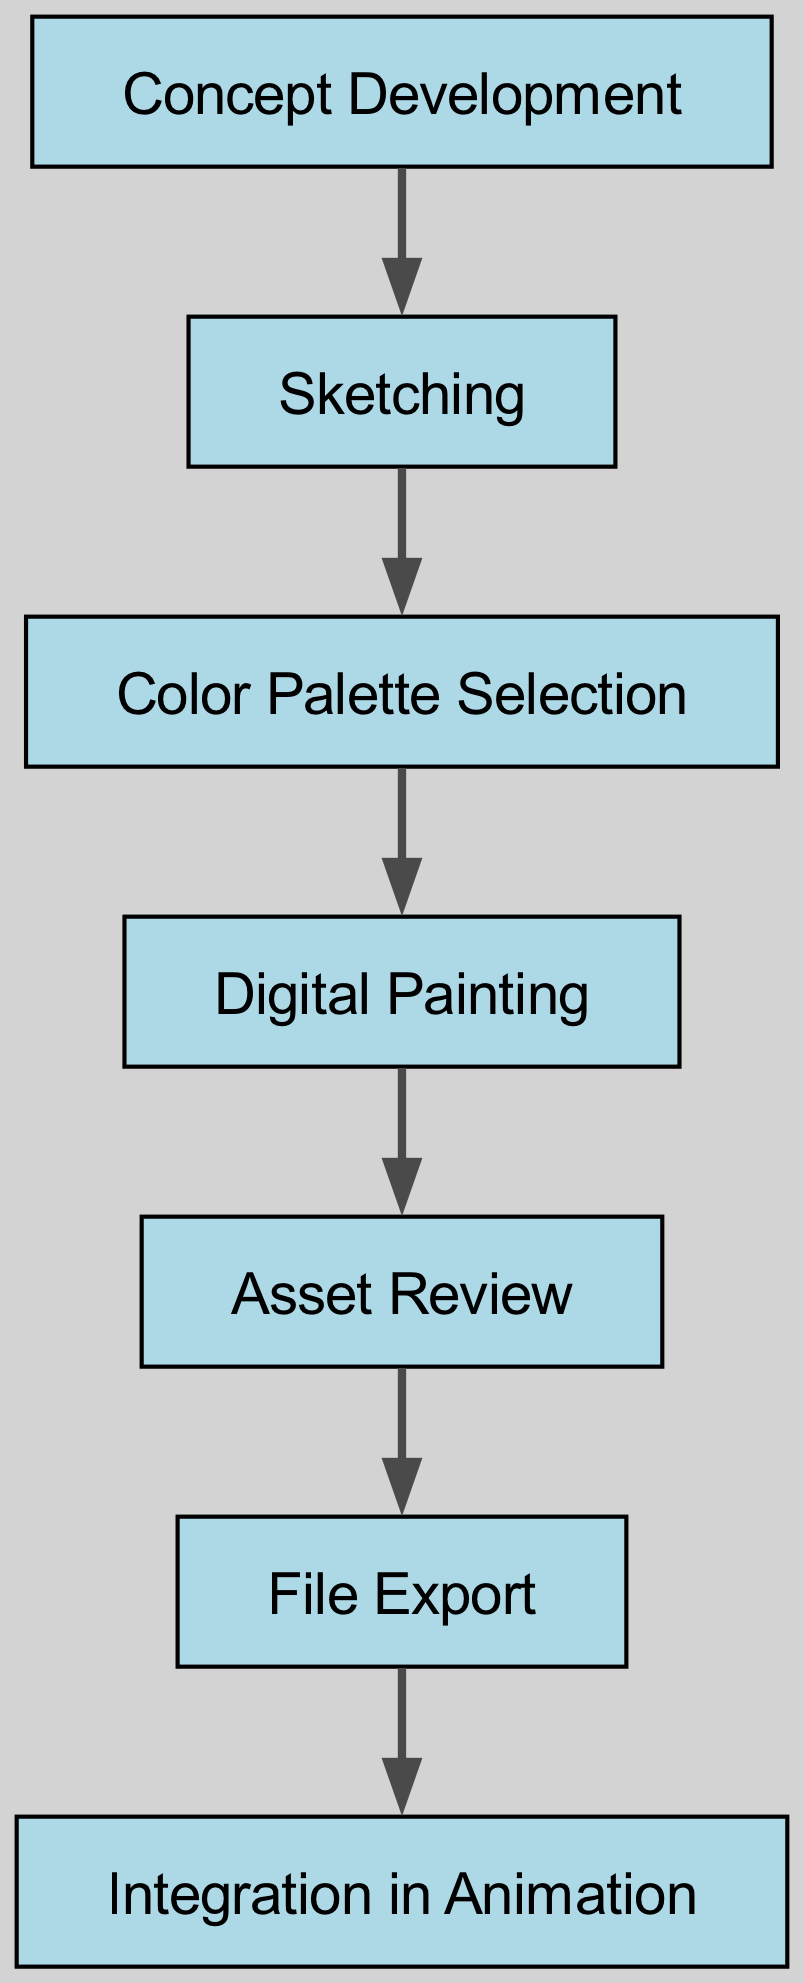What is the first step in the asset management workflow? The diagram shows "Concept Development" as the first node, indicating that this is the initial step in the workflow for managing digital backgrounds.
Answer: Concept Development How many nodes are present in the diagram? The diagram lists six distinct nodes, which represent various steps in the asset management workflow of digital backgrounds.
Answer: Six What step follows "Digital Painting"? In the sequence of steps depicted in the diagram, the step immediately following "Digital Painting" is "Asset Review", which is connected by an edge.
Answer: Asset Review What is the last step in the asset management workflow? The final node in the directed graph is "Integration in Animation", indicating that this is the last step where the assets are incorporated into the animation process.
Answer: Integration in Animation What is the relationship between "Sketching" and "Color Palette Selection"? The diagram illustrates a directed edge from "Sketching" to "Color Palette Selection", indicating that the latter follows as a direct subsequent step after the former in the workflow.
Answer: Sequential relationship Which node has the highest number of outgoing edges? Each node has only one outgoing edge except for "Integration in Animation", which has none as it is the last node. Therefore, the nodes "Concept Development", "Sketching", "Color Palette Selection", "Digital Painting", and "Asset Review" each have one outgoing edge.
Answer: None Which two steps are connected directly by an edge? A direct connection exists between any two consecutive steps in the workflow, such as "Color Palette Selection" directly leading to "Digital Painting", demonstrating the flow of the process.
Answer: Color Palette Selection and Digital Painting What node precedes "File Export"? According to the directed graph, the node directly preceding "File Export" is "Asset Review", which indicates the necessary evaluation before exporting files.
Answer: Asset Review What is the total number of edges in the diagram? The diagram contains five edges, representing the connections between the various steps in the asset management workflow, illustrating the direct flow from one step to the next.
Answer: Five 